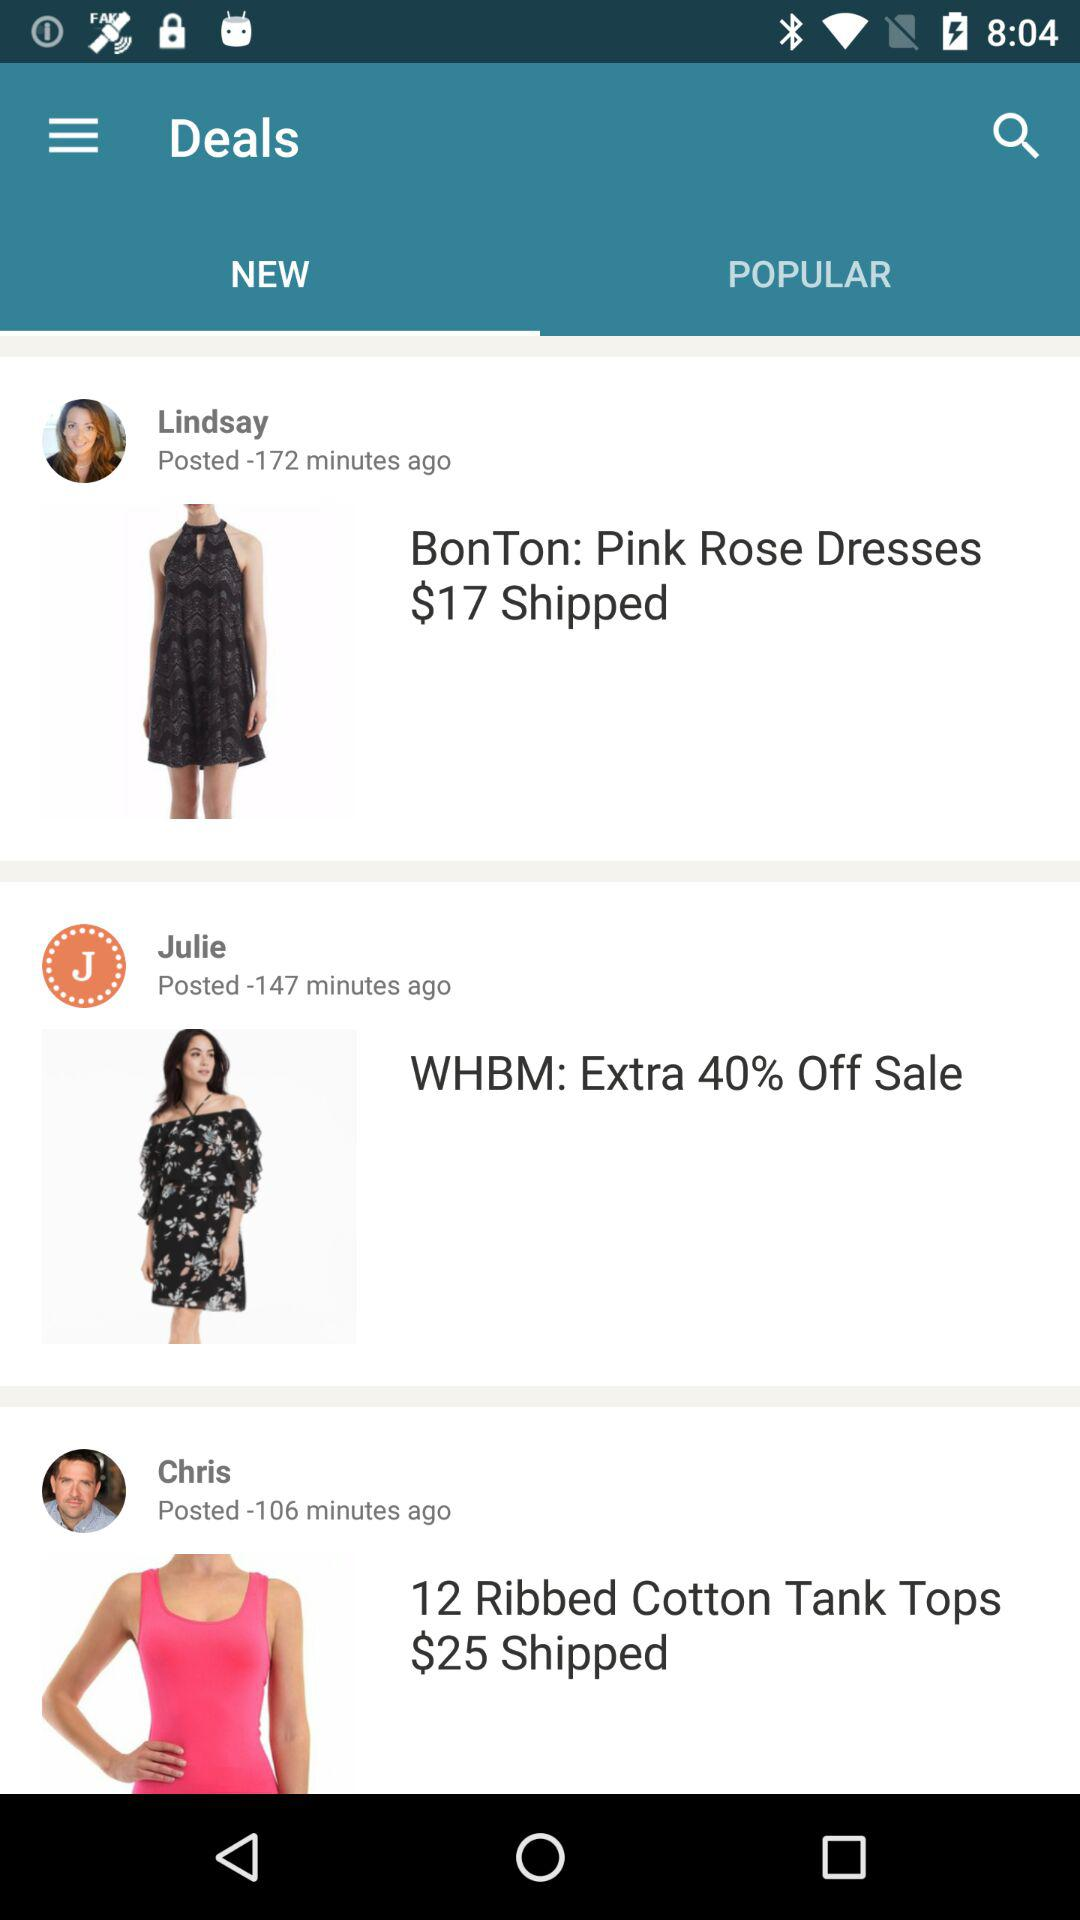When did Lindsay post? Lindsay posted 172 minutes ago. 